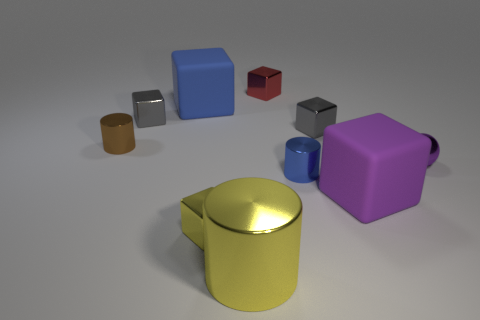Is there a big brown cylinder?
Give a very brief answer. No. What is the material of the big block to the left of the matte thing that is on the right side of the big cube that is behind the large purple object?
Keep it short and to the point. Rubber. Are there fewer purple metallic things behind the tiny brown metal thing than tiny brown matte cubes?
Your response must be concise. No. There is a yellow cube that is the same size as the ball; what is it made of?
Keep it short and to the point. Metal. What is the size of the metallic thing that is right of the blue metallic thing and on the left side of the tiny purple metal thing?
Your response must be concise. Small. There is a purple object that is the same shape as the red thing; what is its size?
Your answer should be very brief. Large. How many things are big green cubes or small metal objects in front of the tiny blue thing?
Make the answer very short. 1. What is the shape of the big yellow object?
Provide a short and direct response. Cylinder. What shape is the object left of the block to the left of the large blue object?
Offer a terse response. Cylinder. There is a block that is the same color as the sphere; what is it made of?
Provide a short and direct response. Rubber. 